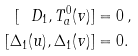Convert formula to latex. <formula><loc_0><loc_0><loc_500><loc_500>[ \ D _ { 1 } , T _ { a } ^ { 0 } ( v ) ] & = 0 \, , \\ [ \Delta _ { 1 } ( u ) , \Delta _ { 1 } ( v ) ] & = 0 .</formula> 